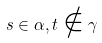Convert formula to latex. <formula><loc_0><loc_0><loc_500><loc_500>s \in \alpha , t \notin \gamma</formula> 